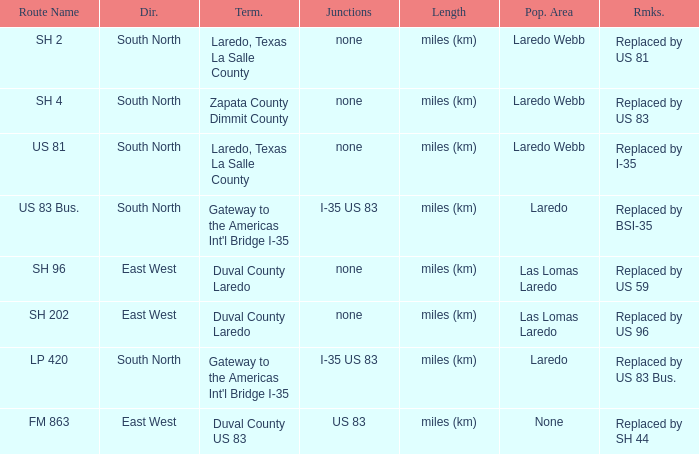Could you parse the entire table as a dict? {'header': ['Route Name', 'Dir.', 'Term.', 'Junctions', 'Length', 'Pop. Area', 'Rmks.'], 'rows': [['SH 2', 'South North', 'Laredo, Texas La Salle County', 'none', 'miles (km)', 'Laredo Webb', 'Replaced by US 81'], ['SH 4', 'South North', 'Zapata County Dimmit County', 'none', 'miles (km)', 'Laredo Webb', 'Replaced by US 83'], ['US 81', 'South North', 'Laredo, Texas La Salle County', 'none', 'miles (km)', 'Laredo Webb', 'Replaced by I-35'], ['US 83 Bus.', 'South North', "Gateway to the Americas Int'l Bridge I-35", 'I-35 US 83', 'miles (km)', 'Laredo', 'Replaced by BSI-35'], ['SH 96', 'East West', 'Duval County Laredo', 'none', 'miles (km)', 'Las Lomas Laredo', 'Replaced by US 59'], ['SH 202', 'East West', 'Duval County Laredo', 'none', 'miles (km)', 'Las Lomas Laredo', 'Replaced by US 96'], ['LP 420', 'South North', "Gateway to the Americas Int'l Bridge I-35", 'I-35 US 83', 'miles (km)', 'Laredo', 'Replaced by US 83 Bus.'], ['FM 863', 'East West', 'Duval County US 83', 'US 83', 'miles (km)', 'None', 'Replaced by SH 44']]} Which junctions have "replaced by bsi-35" listed in their remarks section? I-35 US 83. 